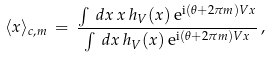Convert formula to latex. <formula><loc_0><loc_0><loc_500><loc_500>\langle x \rangle _ { c , m } \, = \, \frac { \int \, d x \, x \, h _ { V } ( x ) \, { \mathrm e } ^ { { \mathrm i } ( \theta + 2 \pi m ) V x } } { \int \, d x \, h _ { V } ( x ) \, { \mathrm e } ^ { { \mathrm i } ( \theta + 2 \pi m ) V x } } \, ,</formula> 